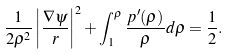Convert formula to latex. <formula><loc_0><loc_0><loc_500><loc_500>\frac { 1 } { 2 \rho ^ { 2 } } \left | \frac { \nabla \psi } { r } \right | ^ { 2 } + \int ^ { \rho } _ { 1 } \frac { p ^ { \prime } ( \rho ) } { \rho } d \rho = \frac { 1 } { 2 } .</formula> 